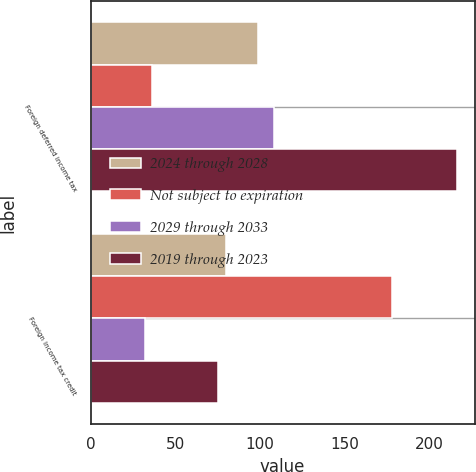Convert chart to OTSL. <chart><loc_0><loc_0><loc_500><loc_500><stacked_bar_chart><ecel><fcel>Foreign deferred income tax<fcel>Foreign income tax credit<nl><fcel>2024 through 2028<fcel>99<fcel>80<nl><fcel>Not subject to expiration<fcel>36<fcel>178<nl><fcel>2029 through 2033<fcel>108<fcel>32<nl><fcel>2019 through 2023<fcel>216<fcel>75<nl></chart> 